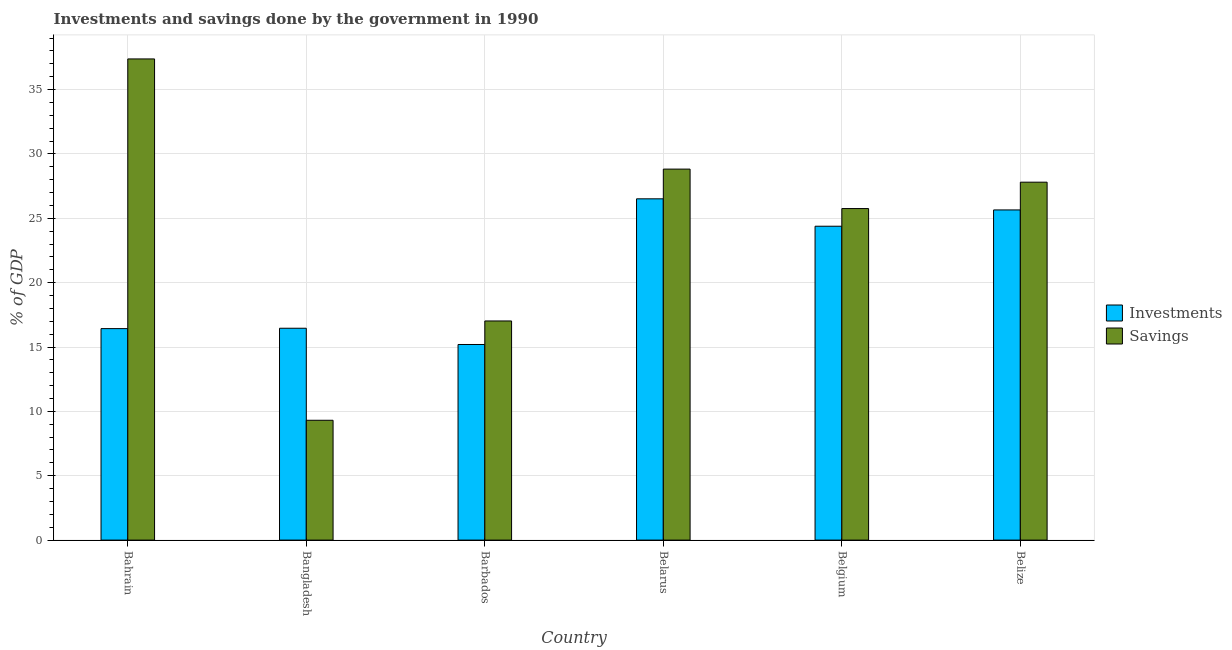How many groups of bars are there?
Offer a terse response. 6. How many bars are there on the 4th tick from the right?
Provide a short and direct response. 2. What is the label of the 1st group of bars from the left?
Ensure brevity in your answer.  Bahrain. What is the investments of government in Barbados?
Provide a short and direct response. 15.2. Across all countries, what is the maximum investments of government?
Offer a terse response. 26.51. Across all countries, what is the minimum savings of government?
Ensure brevity in your answer.  9.31. In which country was the investments of government maximum?
Give a very brief answer. Belarus. In which country was the investments of government minimum?
Offer a terse response. Barbados. What is the total investments of government in the graph?
Offer a terse response. 124.63. What is the difference between the investments of government in Belgium and that in Belize?
Make the answer very short. -1.27. What is the difference between the investments of government in Belarus and the savings of government in Belgium?
Offer a terse response. 0.76. What is the average savings of government per country?
Your response must be concise. 24.35. What is the difference between the investments of government and savings of government in Bangladesh?
Offer a very short reply. 7.15. What is the ratio of the investments of government in Belarus to that in Belize?
Keep it short and to the point. 1.03. What is the difference between the highest and the second highest investments of government?
Your answer should be compact. 0.86. What is the difference between the highest and the lowest savings of government?
Offer a very short reply. 28.07. In how many countries, is the savings of government greater than the average savings of government taken over all countries?
Keep it short and to the point. 4. What does the 1st bar from the left in Belize represents?
Offer a terse response. Investments. What does the 1st bar from the right in Bahrain represents?
Your response must be concise. Savings. How many bars are there?
Offer a very short reply. 12. Are all the bars in the graph horizontal?
Keep it short and to the point. No. What is the difference between two consecutive major ticks on the Y-axis?
Make the answer very short. 5. How many legend labels are there?
Keep it short and to the point. 2. What is the title of the graph?
Your answer should be very brief. Investments and savings done by the government in 1990. Does "Travel Items" appear as one of the legend labels in the graph?
Your answer should be compact. No. What is the label or title of the X-axis?
Ensure brevity in your answer.  Country. What is the label or title of the Y-axis?
Your response must be concise. % of GDP. What is the % of GDP in Investments in Bahrain?
Offer a very short reply. 16.43. What is the % of GDP of Savings in Bahrain?
Ensure brevity in your answer.  37.38. What is the % of GDP of Investments in Bangladesh?
Provide a short and direct response. 16.46. What is the % of GDP of Savings in Bangladesh?
Provide a short and direct response. 9.31. What is the % of GDP of Investments in Barbados?
Provide a succinct answer. 15.2. What is the % of GDP in Savings in Barbados?
Make the answer very short. 17.02. What is the % of GDP of Investments in Belarus?
Your response must be concise. 26.51. What is the % of GDP of Savings in Belarus?
Your answer should be compact. 28.82. What is the % of GDP in Investments in Belgium?
Provide a short and direct response. 24.38. What is the % of GDP of Savings in Belgium?
Your answer should be compact. 25.76. What is the % of GDP of Investments in Belize?
Your response must be concise. 25.65. What is the % of GDP of Savings in Belize?
Your answer should be compact. 27.81. Across all countries, what is the maximum % of GDP of Investments?
Give a very brief answer. 26.51. Across all countries, what is the maximum % of GDP of Savings?
Provide a succinct answer. 37.38. Across all countries, what is the minimum % of GDP of Investments?
Give a very brief answer. 15.2. Across all countries, what is the minimum % of GDP of Savings?
Your answer should be very brief. 9.31. What is the total % of GDP in Investments in the graph?
Offer a very short reply. 124.63. What is the total % of GDP of Savings in the graph?
Make the answer very short. 146.1. What is the difference between the % of GDP in Investments in Bahrain and that in Bangladesh?
Make the answer very short. -0.03. What is the difference between the % of GDP of Savings in Bahrain and that in Bangladesh?
Offer a terse response. 28.07. What is the difference between the % of GDP in Investments in Bahrain and that in Barbados?
Provide a succinct answer. 1.23. What is the difference between the % of GDP in Savings in Bahrain and that in Barbados?
Ensure brevity in your answer.  20.36. What is the difference between the % of GDP of Investments in Bahrain and that in Belarus?
Keep it short and to the point. -10.08. What is the difference between the % of GDP in Savings in Bahrain and that in Belarus?
Offer a terse response. 8.56. What is the difference between the % of GDP of Investments in Bahrain and that in Belgium?
Your answer should be compact. -7.95. What is the difference between the % of GDP in Savings in Bahrain and that in Belgium?
Make the answer very short. 11.62. What is the difference between the % of GDP in Investments in Bahrain and that in Belize?
Provide a short and direct response. -9.22. What is the difference between the % of GDP of Savings in Bahrain and that in Belize?
Your answer should be very brief. 9.58. What is the difference between the % of GDP in Investments in Bangladesh and that in Barbados?
Keep it short and to the point. 1.26. What is the difference between the % of GDP of Savings in Bangladesh and that in Barbados?
Offer a very short reply. -7.72. What is the difference between the % of GDP in Investments in Bangladesh and that in Belarus?
Provide a short and direct response. -10.05. What is the difference between the % of GDP in Savings in Bangladesh and that in Belarus?
Make the answer very short. -19.51. What is the difference between the % of GDP of Investments in Bangladesh and that in Belgium?
Your answer should be very brief. -7.93. What is the difference between the % of GDP of Savings in Bangladesh and that in Belgium?
Offer a terse response. -16.45. What is the difference between the % of GDP of Investments in Bangladesh and that in Belize?
Give a very brief answer. -9.19. What is the difference between the % of GDP of Savings in Bangladesh and that in Belize?
Provide a succinct answer. -18.5. What is the difference between the % of GDP in Investments in Barbados and that in Belarus?
Your answer should be compact. -11.32. What is the difference between the % of GDP in Savings in Barbados and that in Belarus?
Make the answer very short. -11.8. What is the difference between the % of GDP of Investments in Barbados and that in Belgium?
Make the answer very short. -9.19. What is the difference between the % of GDP of Savings in Barbados and that in Belgium?
Your answer should be very brief. -8.73. What is the difference between the % of GDP of Investments in Barbados and that in Belize?
Give a very brief answer. -10.45. What is the difference between the % of GDP of Savings in Barbados and that in Belize?
Ensure brevity in your answer.  -10.78. What is the difference between the % of GDP of Investments in Belarus and that in Belgium?
Provide a succinct answer. 2.13. What is the difference between the % of GDP of Savings in Belarus and that in Belgium?
Offer a very short reply. 3.07. What is the difference between the % of GDP of Investments in Belarus and that in Belize?
Ensure brevity in your answer.  0.86. What is the difference between the % of GDP in Savings in Belarus and that in Belize?
Your answer should be compact. 1.02. What is the difference between the % of GDP of Investments in Belgium and that in Belize?
Your answer should be compact. -1.27. What is the difference between the % of GDP in Savings in Belgium and that in Belize?
Provide a succinct answer. -2.05. What is the difference between the % of GDP in Investments in Bahrain and the % of GDP in Savings in Bangladesh?
Offer a terse response. 7.12. What is the difference between the % of GDP of Investments in Bahrain and the % of GDP of Savings in Barbados?
Ensure brevity in your answer.  -0.6. What is the difference between the % of GDP of Investments in Bahrain and the % of GDP of Savings in Belarus?
Make the answer very short. -12.39. What is the difference between the % of GDP of Investments in Bahrain and the % of GDP of Savings in Belgium?
Provide a succinct answer. -9.33. What is the difference between the % of GDP of Investments in Bahrain and the % of GDP of Savings in Belize?
Make the answer very short. -11.38. What is the difference between the % of GDP in Investments in Bangladesh and the % of GDP in Savings in Barbados?
Ensure brevity in your answer.  -0.57. What is the difference between the % of GDP in Investments in Bangladesh and the % of GDP in Savings in Belarus?
Keep it short and to the point. -12.36. What is the difference between the % of GDP in Investments in Bangladesh and the % of GDP in Savings in Belgium?
Make the answer very short. -9.3. What is the difference between the % of GDP of Investments in Bangladesh and the % of GDP of Savings in Belize?
Keep it short and to the point. -11.35. What is the difference between the % of GDP of Investments in Barbados and the % of GDP of Savings in Belarus?
Make the answer very short. -13.63. What is the difference between the % of GDP in Investments in Barbados and the % of GDP in Savings in Belgium?
Keep it short and to the point. -10.56. What is the difference between the % of GDP in Investments in Barbados and the % of GDP in Savings in Belize?
Keep it short and to the point. -12.61. What is the difference between the % of GDP in Investments in Belarus and the % of GDP in Savings in Belgium?
Make the answer very short. 0.76. What is the difference between the % of GDP in Investments in Belarus and the % of GDP in Savings in Belize?
Ensure brevity in your answer.  -1.29. What is the difference between the % of GDP in Investments in Belgium and the % of GDP in Savings in Belize?
Keep it short and to the point. -3.42. What is the average % of GDP of Investments per country?
Your answer should be very brief. 20.77. What is the average % of GDP of Savings per country?
Offer a very short reply. 24.35. What is the difference between the % of GDP of Investments and % of GDP of Savings in Bahrain?
Your response must be concise. -20.95. What is the difference between the % of GDP in Investments and % of GDP in Savings in Bangladesh?
Offer a terse response. 7.15. What is the difference between the % of GDP in Investments and % of GDP in Savings in Barbados?
Offer a terse response. -1.83. What is the difference between the % of GDP of Investments and % of GDP of Savings in Belarus?
Offer a very short reply. -2.31. What is the difference between the % of GDP in Investments and % of GDP in Savings in Belgium?
Provide a short and direct response. -1.37. What is the difference between the % of GDP of Investments and % of GDP of Savings in Belize?
Offer a terse response. -2.15. What is the ratio of the % of GDP of Savings in Bahrain to that in Bangladesh?
Provide a short and direct response. 4.02. What is the ratio of the % of GDP in Investments in Bahrain to that in Barbados?
Your response must be concise. 1.08. What is the ratio of the % of GDP of Savings in Bahrain to that in Barbados?
Give a very brief answer. 2.2. What is the ratio of the % of GDP of Investments in Bahrain to that in Belarus?
Your answer should be very brief. 0.62. What is the ratio of the % of GDP of Savings in Bahrain to that in Belarus?
Your answer should be very brief. 1.3. What is the ratio of the % of GDP of Investments in Bahrain to that in Belgium?
Keep it short and to the point. 0.67. What is the ratio of the % of GDP of Savings in Bahrain to that in Belgium?
Your response must be concise. 1.45. What is the ratio of the % of GDP in Investments in Bahrain to that in Belize?
Your answer should be very brief. 0.64. What is the ratio of the % of GDP in Savings in Bahrain to that in Belize?
Ensure brevity in your answer.  1.34. What is the ratio of the % of GDP of Investments in Bangladesh to that in Barbados?
Ensure brevity in your answer.  1.08. What is the ratio of the % of GDP in Savings in Bangladesh to that in Barbados?
Offer a very short reply. 0.55. What is the ratio of the % of GDP in Investments in Bangladesh to that in Belarus?
Provide a succinct answer. 0.62. What is the ratio of the % of GDP in Savings in Bangladesh to that in Belarus?
Offer a very short reply. 0.32. What is the ratio of the % of GDP of Investments in Bangladesh to that in Belgium?
Keep it short and to the point. 0.68. What is the ratio of the % of GDP of Savings in Bangladesh to that in Belgium?
Offer a very short reply. 0.36. What is the ratio of the % of GDP of Investments in Bangladesh to that in Belize?
Make the answer very short. 0.64. What is the ratio of the % of GDP of Savings in Bangladesh to that in Belize?
Your answer should be very brief. 0.33. What is the ratio of the % of GDP of Investments in Barbados to that in Belarus?
Make the answer very short. 0.57. What is the ratio of the % of GDP of Savings in Barbados to that in Belarus?
Provide a succinct answer. 0.59. What is the ratio of the % of GDP in Investments in Barbados to that in Belgium?
Your answer should be very brief. 0.62. What is the ratio of the % of GDP in Savings in Barbados to that in Belgium?
Make the answer very short. 0.66. What is the ratio of the % of GDP in Investments in Barbados to that in Belize?
Provide a succinct answer. 0.59. What is the ratio of the % of GDP of Savings in Barbados to that in Belize?
Make the answer very short. 0.61. What is the ratio of the % of GDP in Investments in Belarus to that in Belgium?
Keep it short and to the point. 1.09. What is the ratio of the % of GDP in Savings in Belarus to that in Belgium?
Offer a terse response. 1.12. What is the ratio of the % of GDP in Investments in Belarus to that in Belize?
Your answer should be very brief. 1.03. What is the ratio of the % of GDP in Savings in Belarus to that in Belize?
Offer a very short reply. 1.04. What is the ratio of the % of GDP of Investments in Belgium to that in Belize?
Your response must be concise. 0.95. What is the ratio of the % of GDP of Savings in Belgium to that in Belize?
Give a very brief answer. 0.93. What is the difference between the highest and the second highest % of GDP in Investments?
Make the answer very short. 0.86. What is the difference between the highest and the second highest % of GDP in Savings?
Provide a short and direct response. 8.56. What is the difference between the highest and the lowest % of GDP in Investments?
Offer a very short reply. 11.32. What is the difference between the highest and the lowest % of GDP of Savings?
Give a very brief answer. 28.07. 